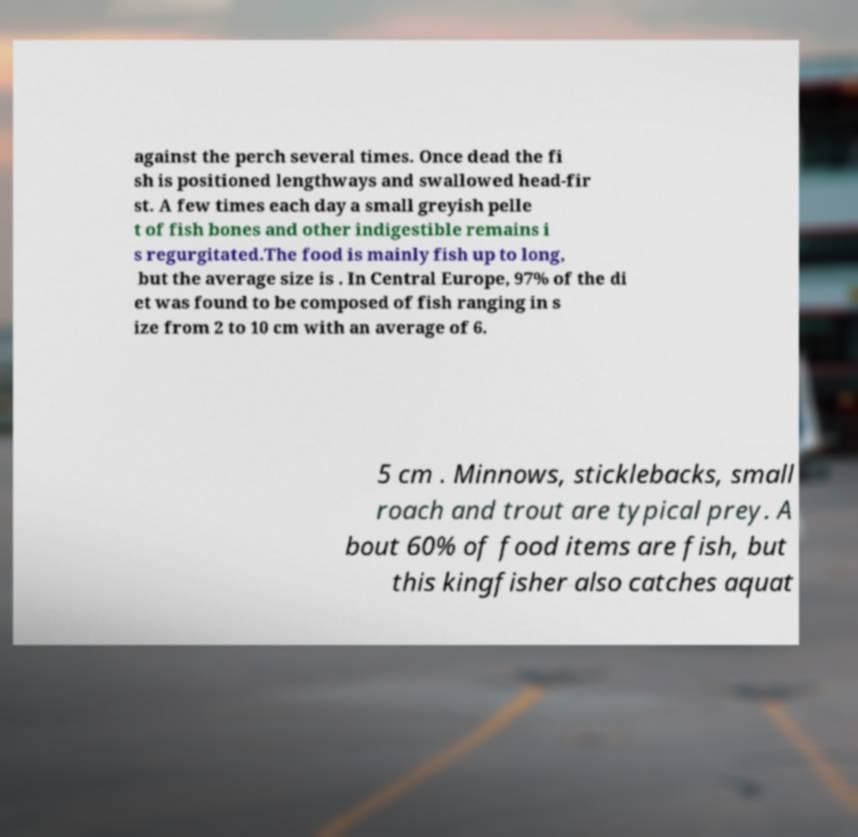Could you extract and type out the text from this image? against the perch several times. Once dead the fi sh is positioned lengthways and swallowed head-fir st. A few times each day a small greyish pelle t of fish bones and other indigestible remains i s regurgitated.The food is mainly fish up to long, but the average size is . In Central Europe, 97% of the di et was found to be composed of fish ranging in s ize from 2 to 10 cm with an average of 6. 5 cm . Minnows, sticklebacks, small roach and trout are typical prey. A bout 60% of food items are fish, but this kingfisher also catches aquat 